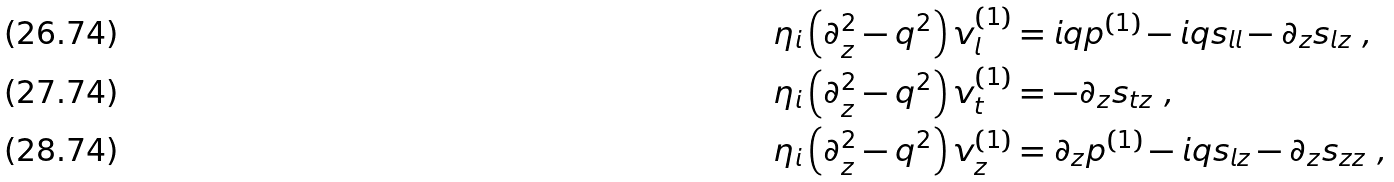Convert formula to latex. <formula><loc_0><loc_0><loc_500><loc_500>\eta _ { i } \left ( \partial _ { z } ^ { 2 } - q ^ { 2 } \right ) v _ { l } ^ { ( 1 ) } & = i q p ^ { ( 1 ) } - i q s _ { l l } - \partial _ { z } s _ { l z } \ , \\ \eta _ { i } \left ( \partial _ { z } ^ { 2 } - q ^ { 2 } \right ) v _ { t } ^ { ( 1 ) } & = - \partial _ { z } s _ { t z } \ , \\ \eta _ { i } \left ( \partial _ { z } ^ { 2 } - q ^ { 2 } \right ) v _ { z } ^ { ( 1 ) } & = \partial _ { z } p ^ { ( 1 ) } - i q s _ { l z } - \partial _ { z } s _ { z z } \ ,</formula> 